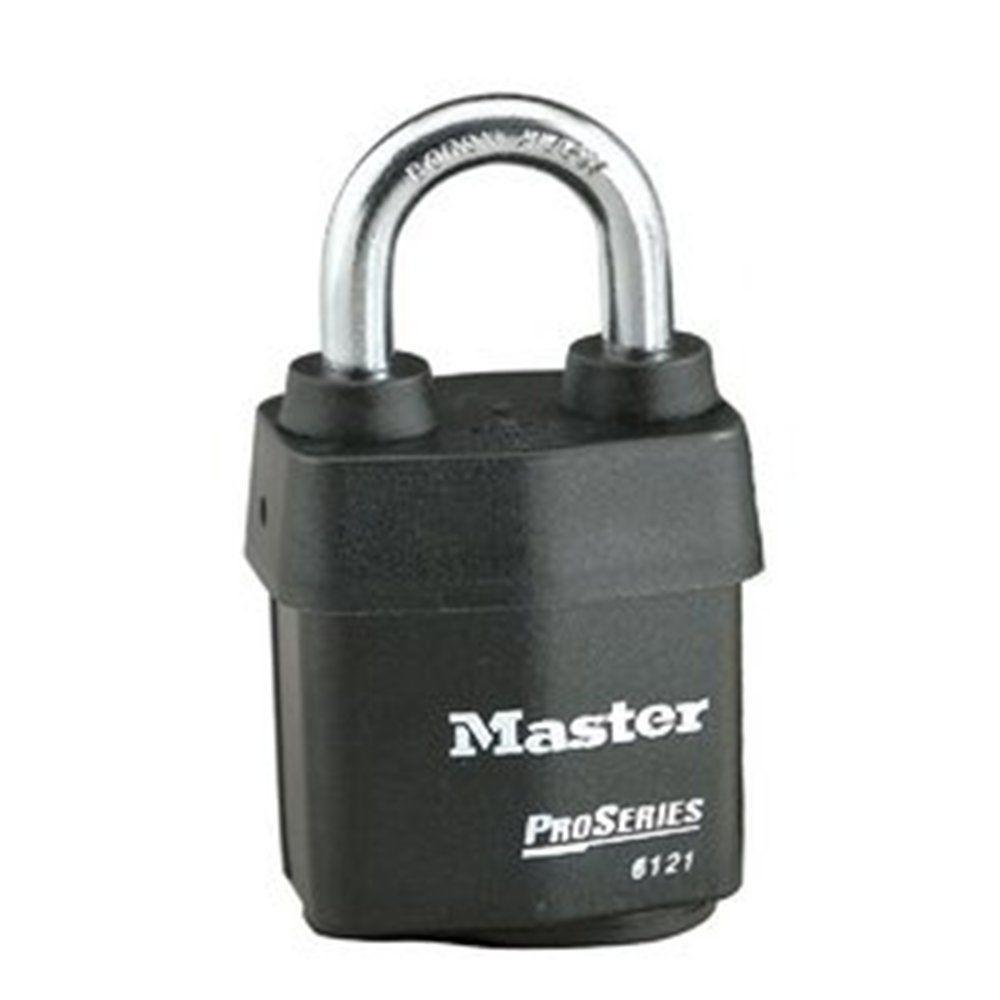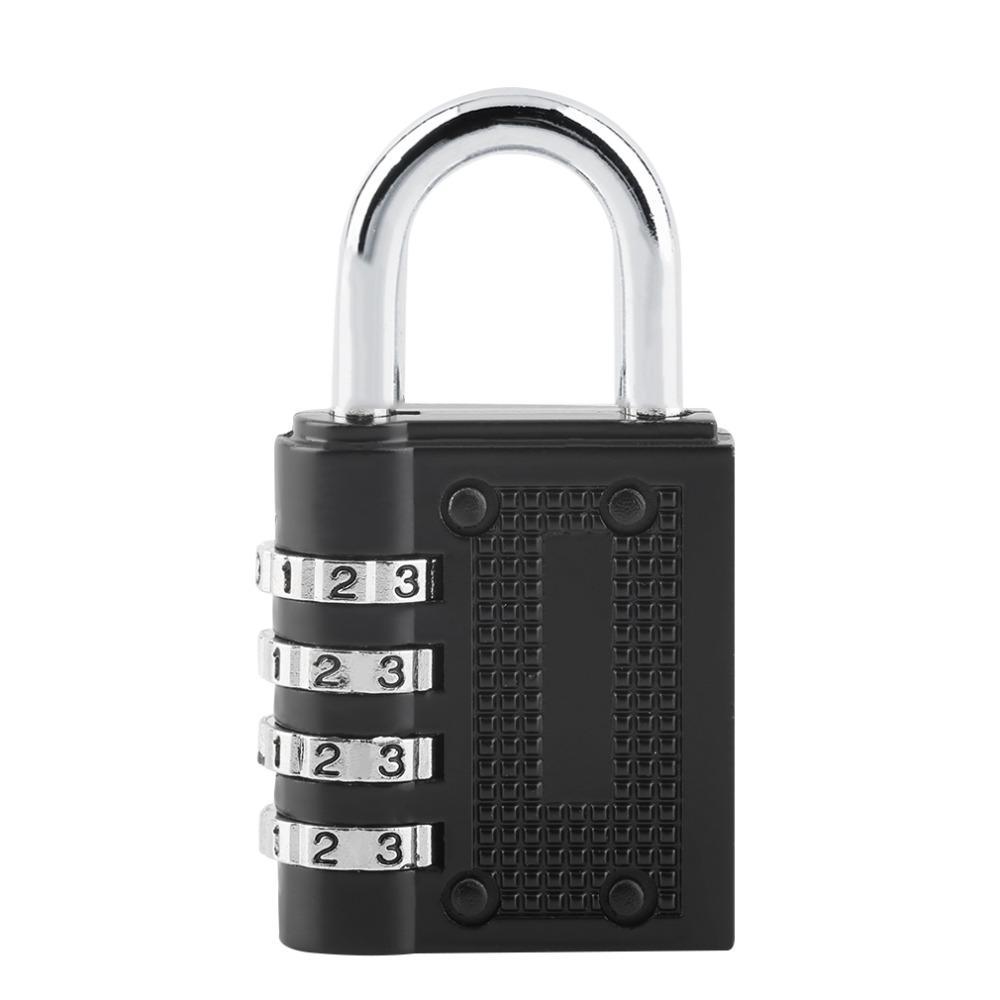The first image is the image on the left, the second image is the image on the right. For the images shown, is this caption "In one image in each pair a lock is unlocked and open." true? Answer yes or no. No. The first image is the image on the left, the second image is the image on the right. Analyze the images presented: Is the assertion "We have two combination locks." valid? Answer yes or no. Yes. 